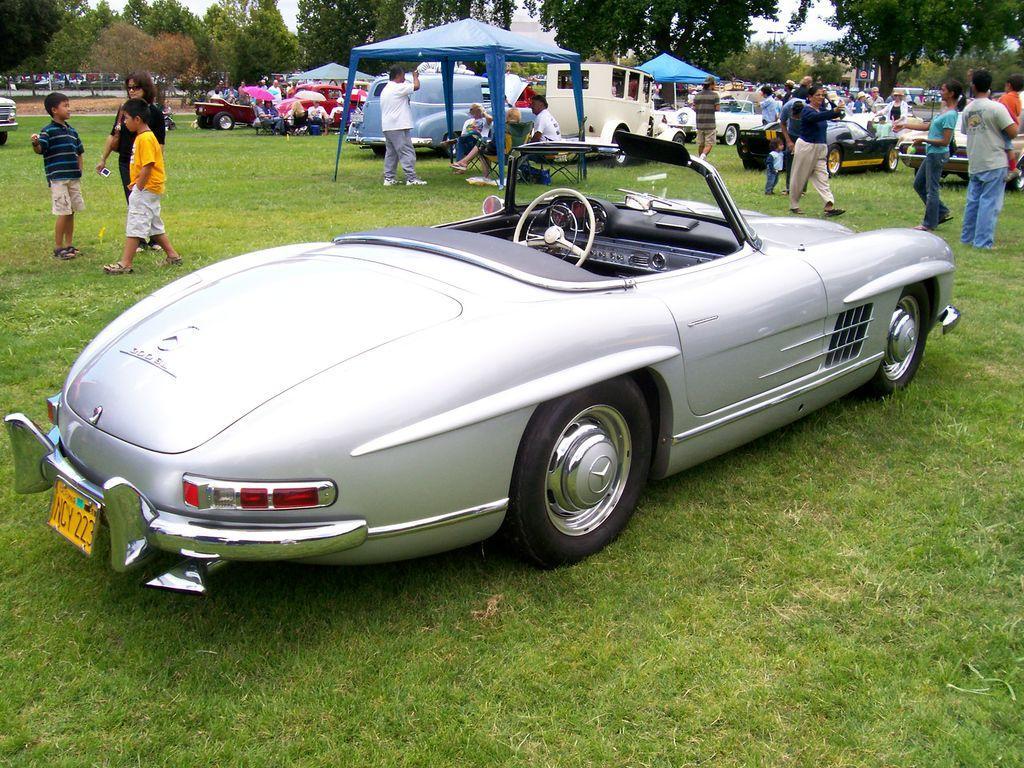Describe this image in one or two sentences. In this image we can see a car placed on the ground. On the backside we can see a group of vehicles and some people standing on the ground. We can also see some grass, umbrellas, a group of people under the tent's, a woman holding a device, a group of trees, a pole and the sky. 